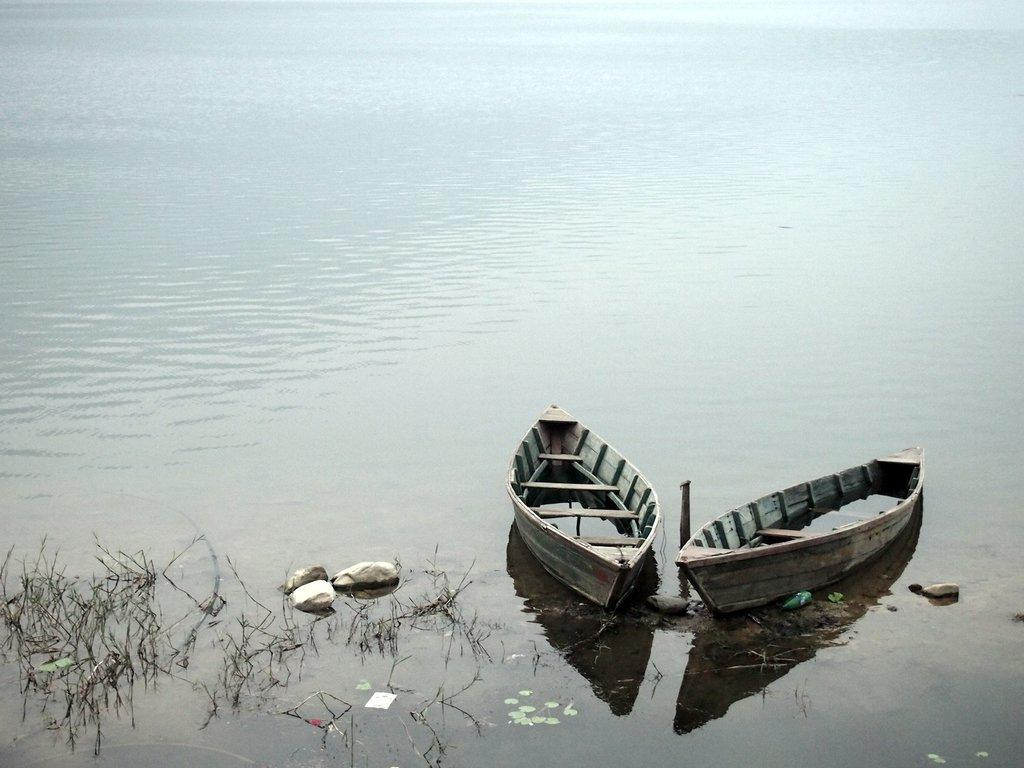How many boats can be seen in the image? There are two boats in the image. What other objects or features are present in the image? There are rocks and grass visible in the image. What type of setting is depicted in the image? The image appears to depict a lake. Where is the door located in the image? There is no door present in the image. Can you tell me how many horses are swimming in the lake in the image? There are no horses present in the image. 